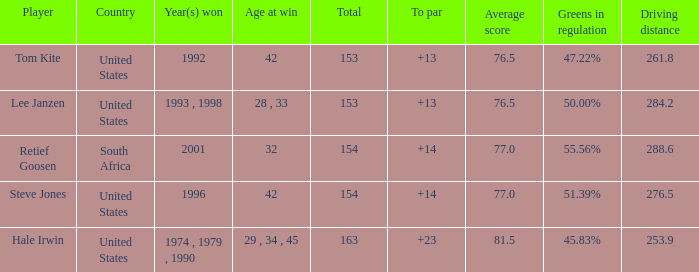In what year did the United States win To par greater than 14 1974 , 1979 , 1990. 